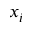<formula> <loc_0><loc_0><loc_500><loc_500>x _ { i }</formula> 